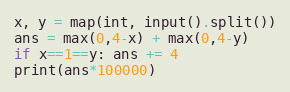Convert code to text. <code><loc_0><loc_0><loc_500><loc_500><_Python_>x, y = map(int, input().split())
ans = max(0,4-x) + max(0,4-y)
if x==1==y: ans += 4
print(ans*100000)</code> 